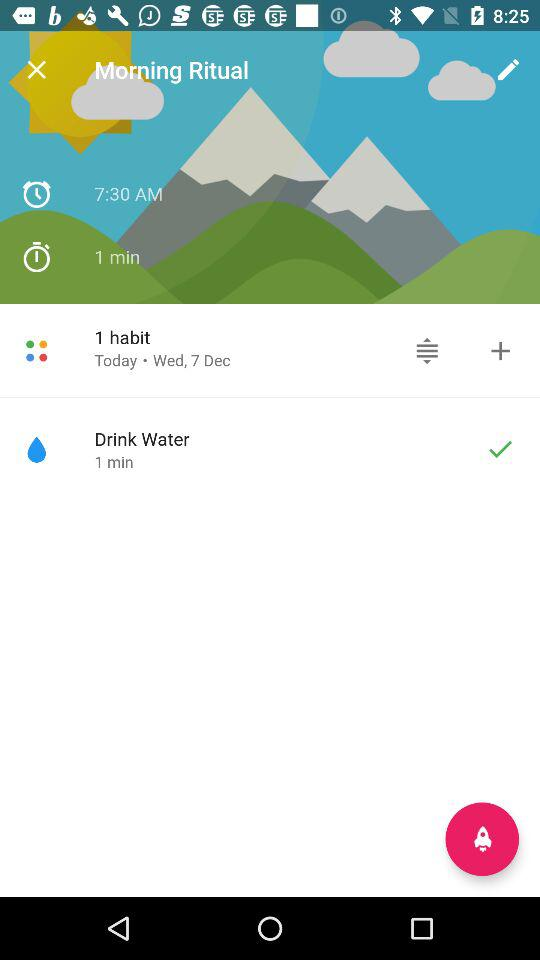How much water should we drink?
When the provided information is insufficient, respond with <no answer>. <no answer> 